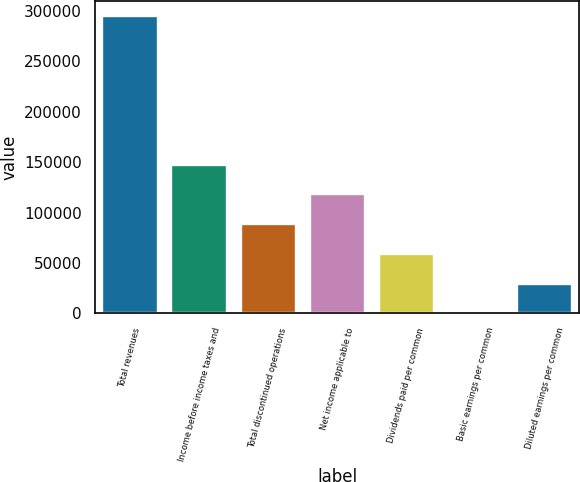<chart> <loc_0><loc_0><loc_500><loc_500><bar_chart><fcel>Total revenues<fcel>Income before income taxes and<fcel>Total discontinued operations<fcel>Net income applicable to<fcel>Dividends paid per common<fcel>Basic earnings per common<fcel>Diluted earnings per common<nl><fcel>294946<fcel>147473<fcel>88483.9<fcel>117978<fcel>58989.3<fcel>0.14<fcel>29494.7<nl></chart> 